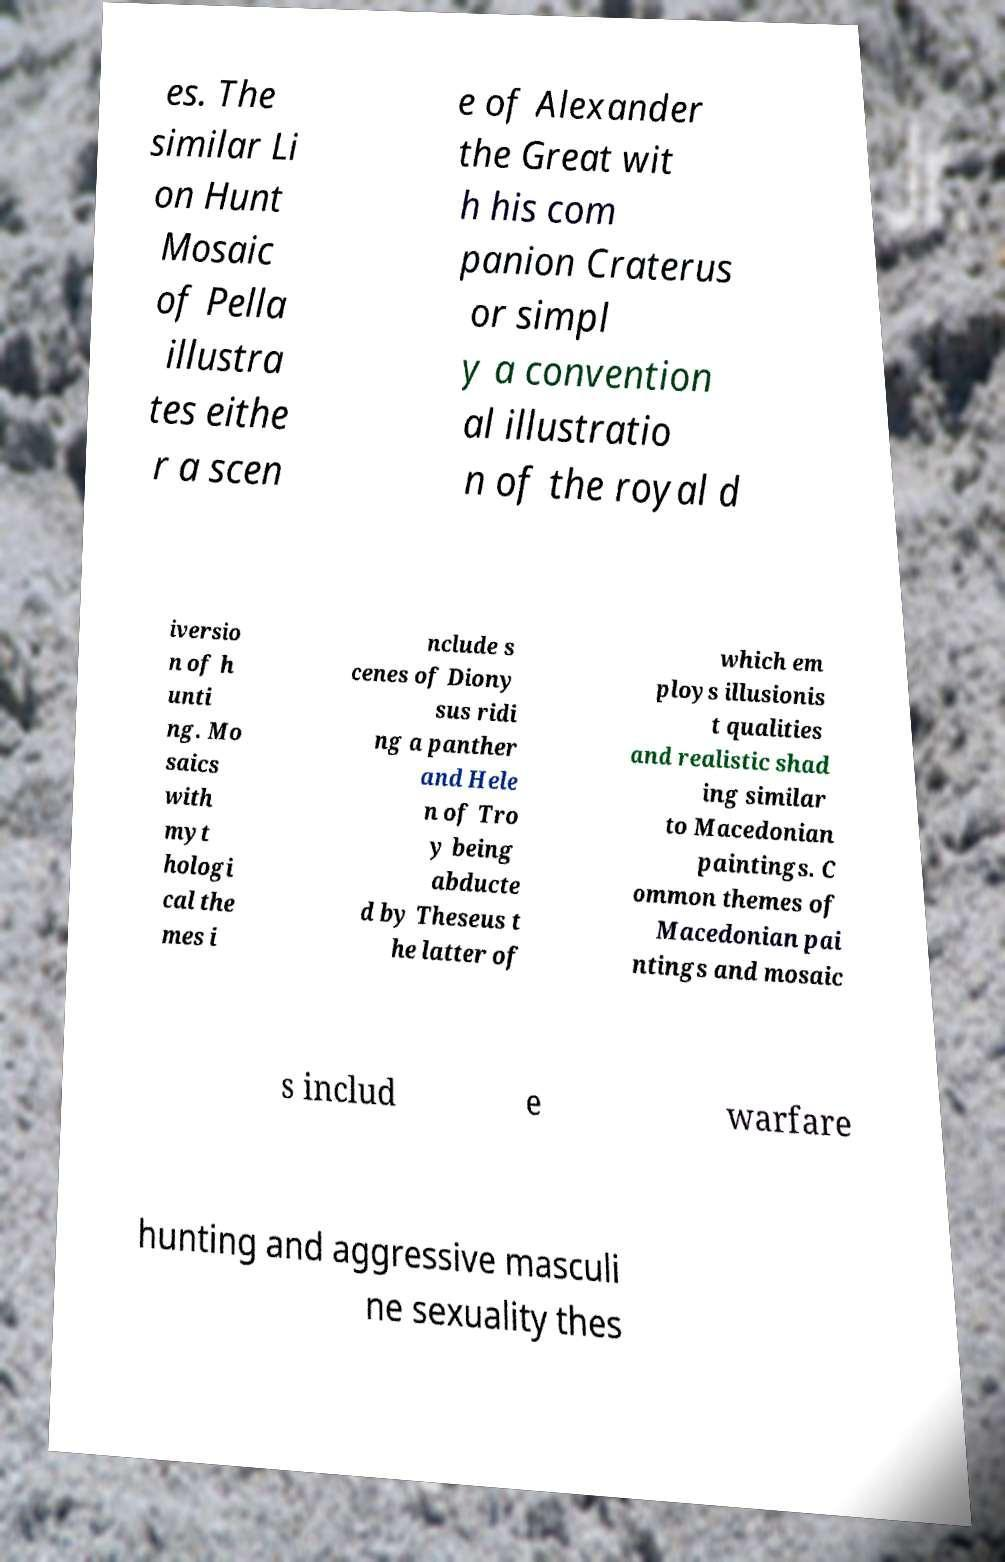Could you assist in decoding the text presented in this image and type it out clearly? es. The similar Li on Hunt Mosaic of Pella illustra tes eithe r a scen e of Alexander the Great wit h his com panion Craterus or simpl y a convention al illustratio n of the royal d iversio n of h unti ng. Mo saics with myt hologi cal the mes i nclude s cenes of Diony sus ridi ng a panther and Hele n of Tro y being abducte d by Theseus t he latter of which em ploys illusionis t qualities and realistic shad ing similar to Macedonian paintings. C ommon themes of Macedonian pai ntings and mosaic s includ e warfare hunting and aggressive masculi ne sexuality thes 